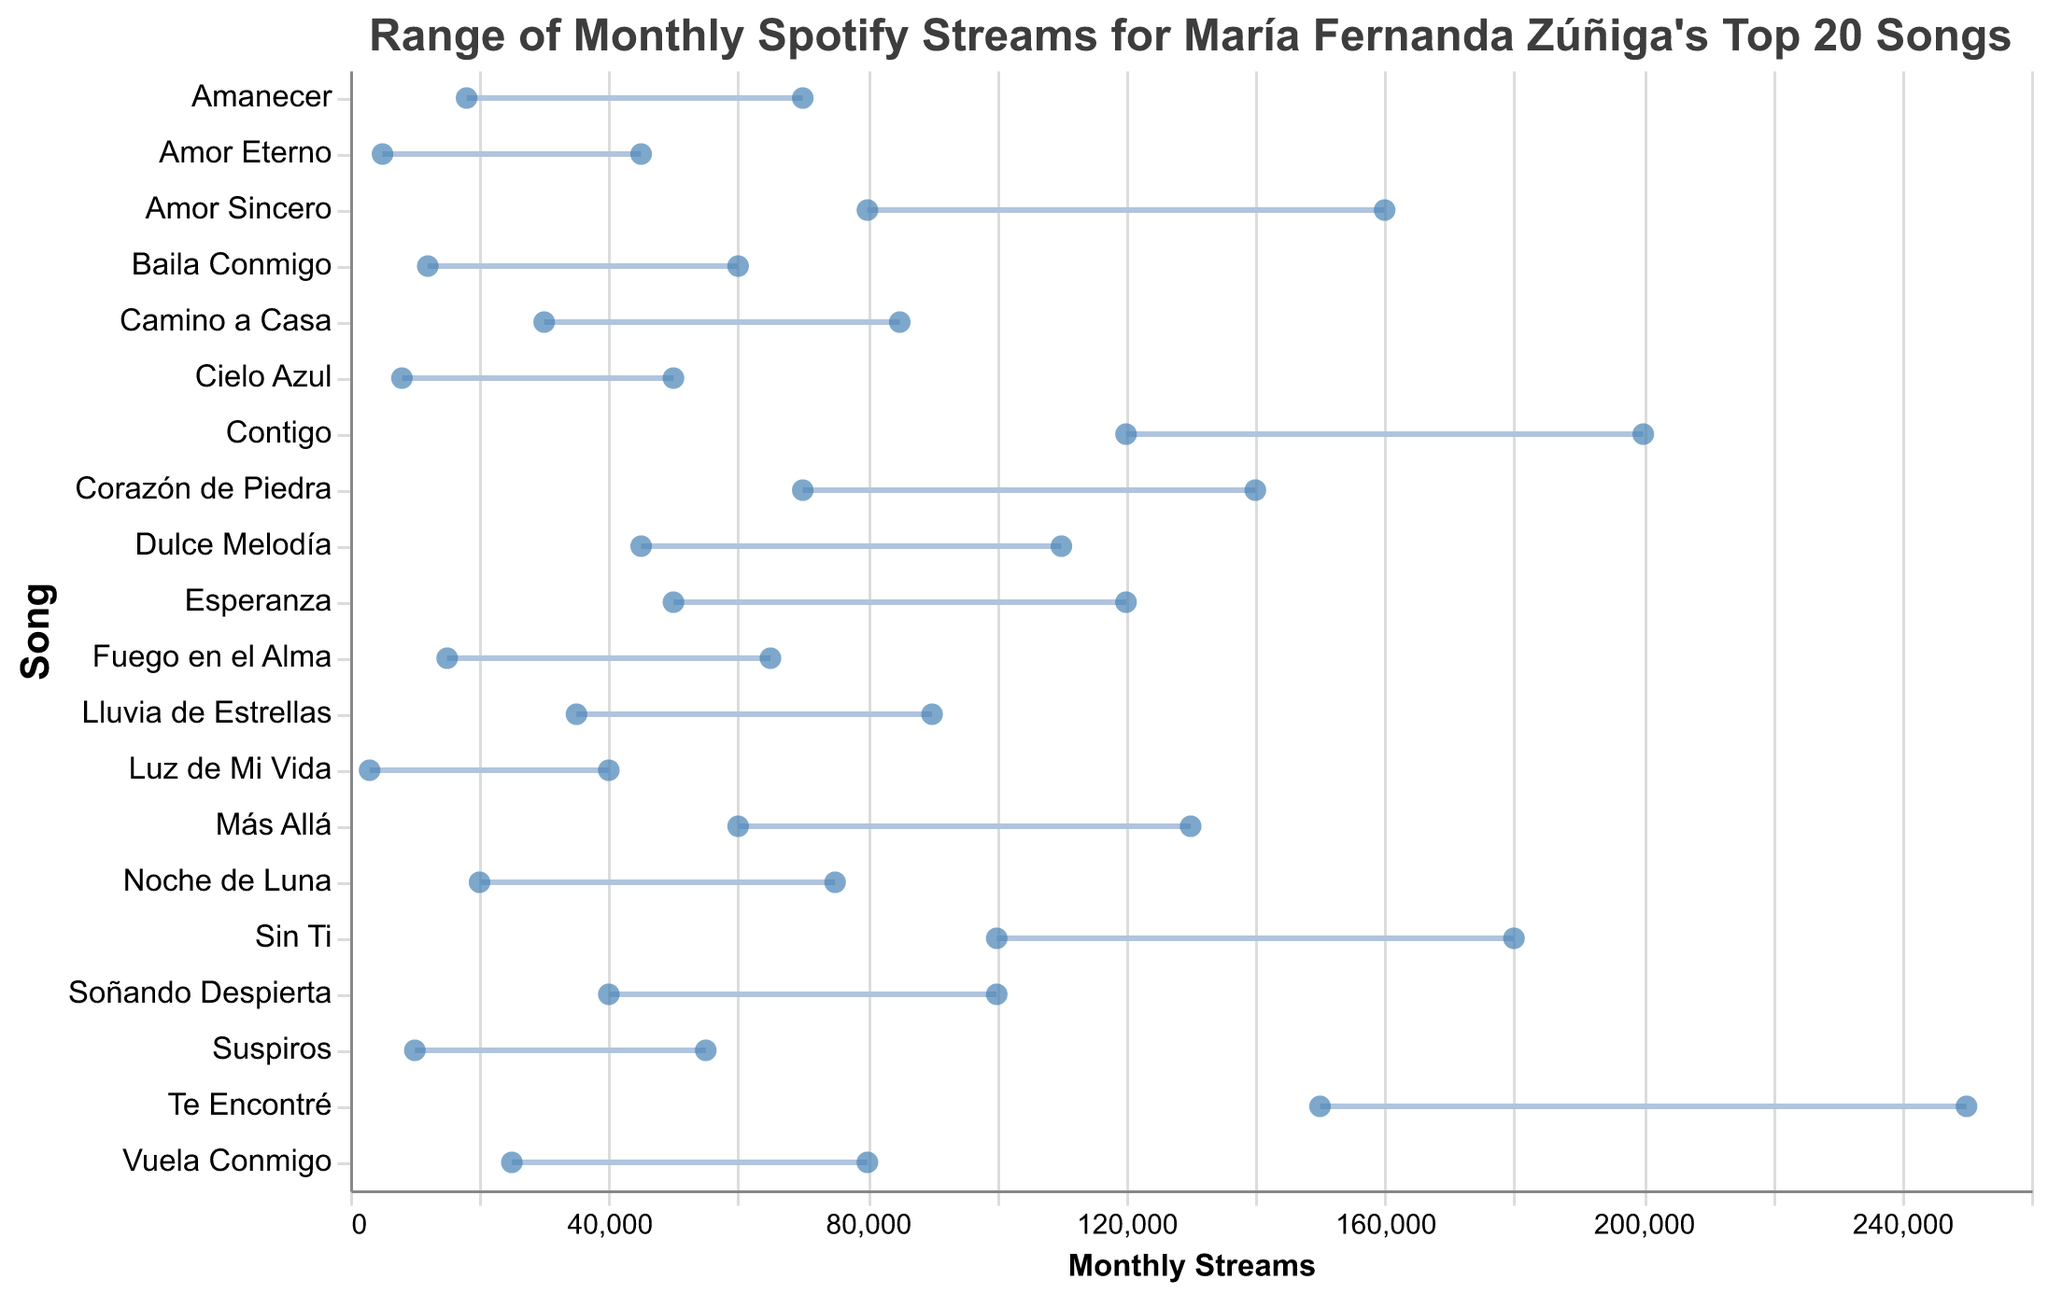What is the title of the plot? The title is usually placed at the top of the plot and provides a summary of the content. In this case, the title is "Range of Monthly Spotify Streams for María Fernanda Zúñiga's Top 20 Songs."
Answer: Range of Monthly Spotify Streams for María Fernanda Zúñiga's Top 20 Songs Which song has the highest maximum monthly streams? To find the song with the highest maximum monthly streams, look for the highest point on the x-axis. "Te Encontré" has the highest maximum value of 250,000 streams.
Answer: Te Encontré How many songs have a minimum monthly stream value of less than 20,000? Check each song's minimum stream value and count those below 20,000. "Luz de Mi Vida," "Amor Eterno," "Cielo Azul," "Suspiros," "Baila Conmigo," and "Fuego en el Alma" meet this criterion.
Answer: 6 What is the range of monthly streams for the song "Amor Sincero"? The range for a song is the difference between its maximum and minimum values. For "Amor Sincero," the range is 160,000 - 80,000.
Answer: 80,000 Which song has the smallest range of monthly streams? Compare the range (difference between max and min streams) of all songs. "Luz de Mi Vida" has the smallest range: 40,000 - 3,000 = 37,000.
Answer: Luz de Mi Vida Which songs have a maximum value of streams equal to or greater than 150,000? Identify songs on the plot where the maximum value reaches or exceeds 150,000. "Te Encontré," "Contigo," "Sin Ti," and "Amor Sincero" meet this criterion.
Answer: Te Encontré, Contigo, Sin Ti, Amor Sincero What is the median minimum stream value across all songs? List all minimum stream values, order them, and find the middle value. Ordered values are: 3,000, 5,000, 8,000, 10,000, 12,000, 15,000, 18,000, 20,000, 25,000, 30,000, 35,000, 40,000, 45,000, 50,000, 60,000, 70,000, 80,000, 100,000, 120,000, 150,000. The median value is the 10th and 11th values, so (30,000 + 35,000) / 2.
Answer: 32,500 Between "Lluvia de Estrellas" and "Camino a Casa," which song has a wider range of monthly streams? Calculate the range for both: "Lluvia de Estrellas" (90,000 - 35,000) = 55,000, "Camino a Casa" (85,000 - 30,000) = 55,000. Both have the same range.
Answer: Both have the same range How many songs have a maximum stream value below 50,000? Identify songs with a maximum stream value less than 50,000. "Luz de Mi Vida," "Amor Eterno," "Cielo Azul," and "Suspiros" fall into this category.
Answer: 4 